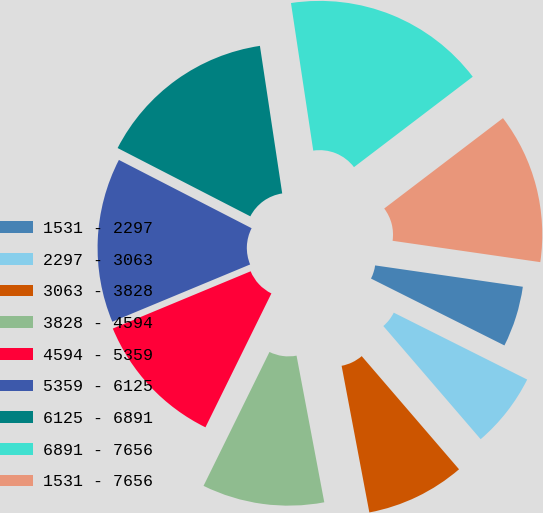Convert chart to OTSL. <chart><loc_0><loc_0><loc_500><loc_500><pie_chart><fcel>1531 - 2297<fcel>2297 - 3063<fcel>3063 - 3828<fcel>3828 - 4594<fcel>4594 - 5359<fcel>5359 - 6125<fcel>6125 - 6891<fcel>6891 - 7656<fcel>1531 - 7656<nl><fcel>5.11%<fcel>6.3%<fcel>8.33%<fcel>10.26%<fcel>11.45%<fcel>13.83%<fcel>15.05%<fcel>17.03%<fcel>12.64%<nl></chart> 